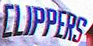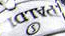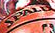What words can you see in these images in sequence, separated by a semicolon? CLIPPERS; #####; ##### 